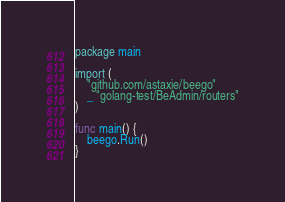Convert code to text. <code><loc_0><loc_0><loc_500><loc_500><_Go_>package main

import (
	"github.com/astaxie/beego"
	_ "golang-test/BeAdmin/routers"
)

func main() {
	beego.Run()
}
</code> 